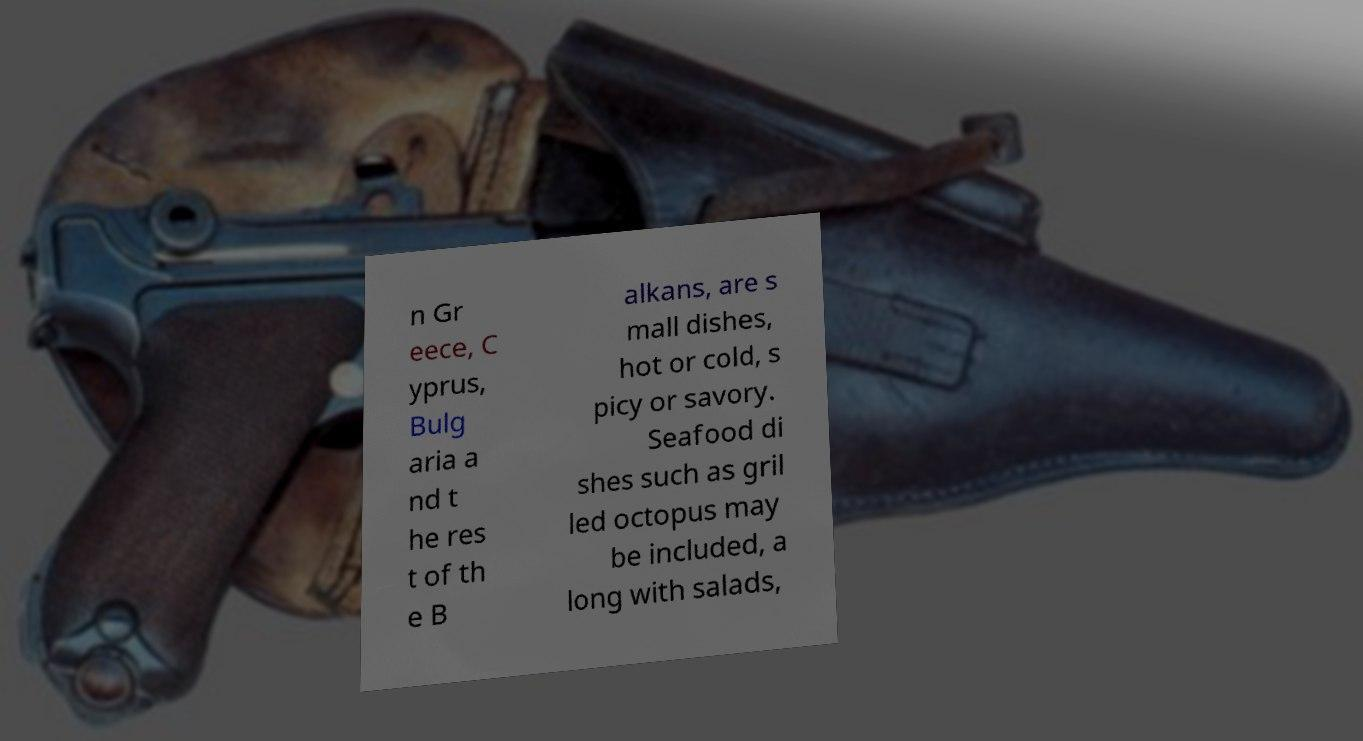For documentation purposes, I need the text within this image transcribed. Could you provide that? n Gr eece, C yprus, Bulg aria a nd t he res t of th e B alkans, are s mall dishes, hot or cold, s picy or savory. Seafood di shes such as gril led octopus may be included, a long with salads, 